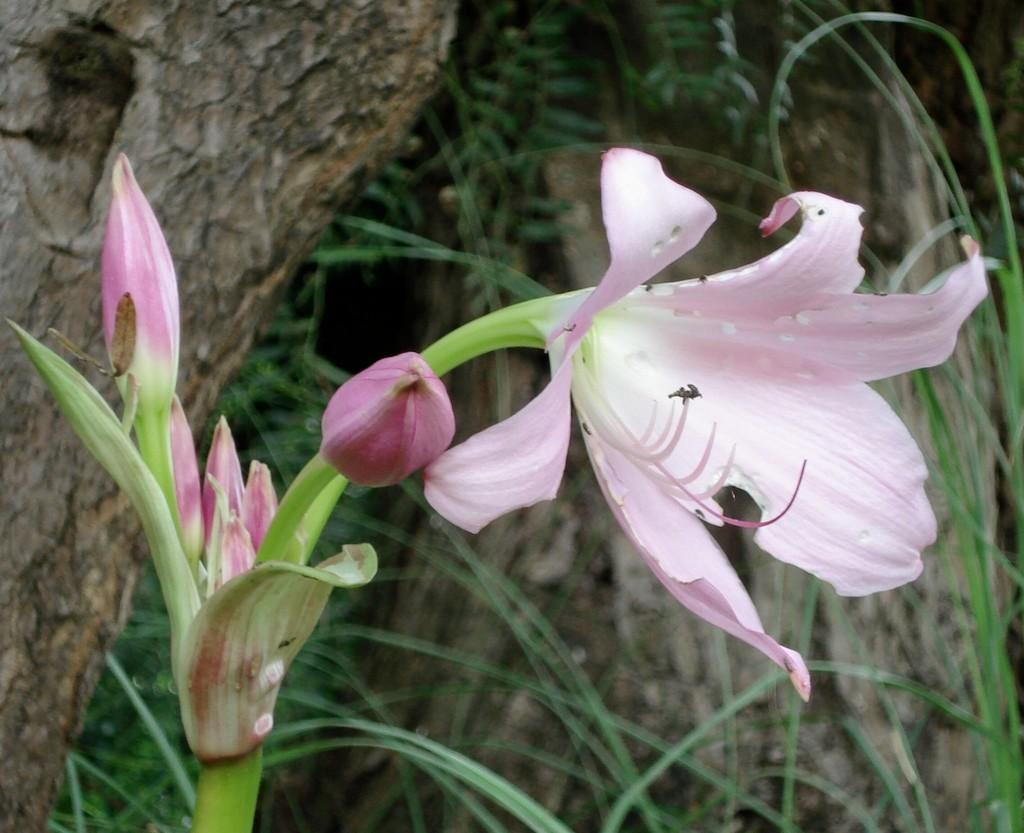What is the main subject in the center of the image? There is a flower in the center of the image. What can be seen in the background of the image? There is a tree and plants in the background of the image. What type of string is wrapped around the flower in the image? There is no string present in the image; the flower is not wrapped in any string. 